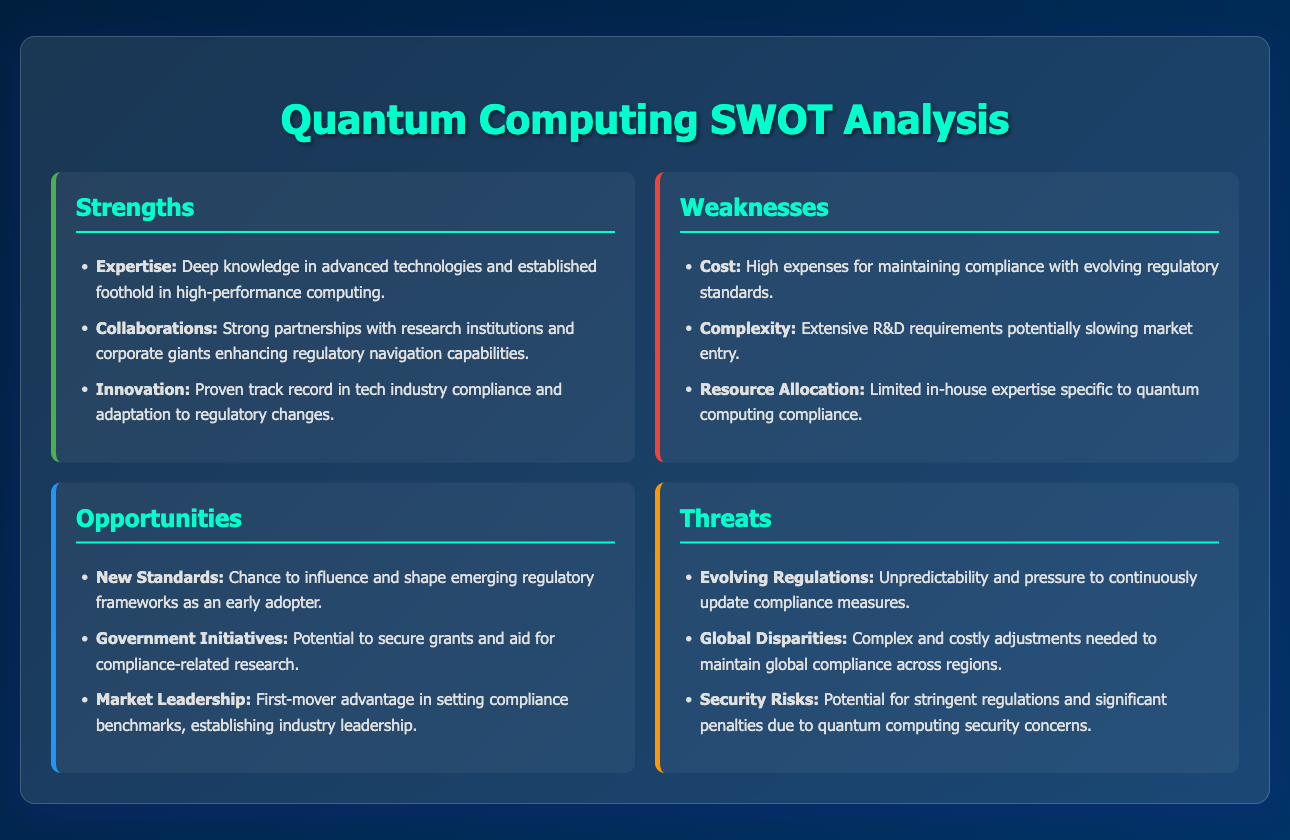what are the strengths listed in the analysis? The strengths section contains three specific points about expertise, collaborations, and innovation.
Answer: Expertise, Collaborations, Innovation what is one of the weaknesses mentioned? The weaknesses section includes three specific issues, and any one of them could be mentioned in response.
Answer: Cost what opportunity is highlighted in the analysis? The opportunities section identifies three promises, and one of these can be cited as an example.
Answer: New Standards how many threats are outlined in the document? The threats section includes three specific threats related to regulatory challenges in quantum computing.
Answer: Three what is mentioned as a threat concerning regulations? One of the threats directly relates to the unpredictability of regulatory changes faced by companies.
Answer: Evolving Regulations which strength emphasizes partnerships? The strengths section includes collaborations as a key aspect of the corporation's capabilities in navigating regulations.
Answer: Collaborations what does the opportunity 'Government Initiatives' refer to? The opportunity highlights potential benefits from public support, such as grants for compliance research.
Answer: Grants and aid what challenge relates to resource allocation? The document mentions limited in-house expertise specific to compliance in quantum computing as a challenge.
Answer: Limited in-house expertise which section discusses potential penalties? The threats section discusses significant penalties that may arise due to security concerns in quantum computing compliance.
Answer: Threats 